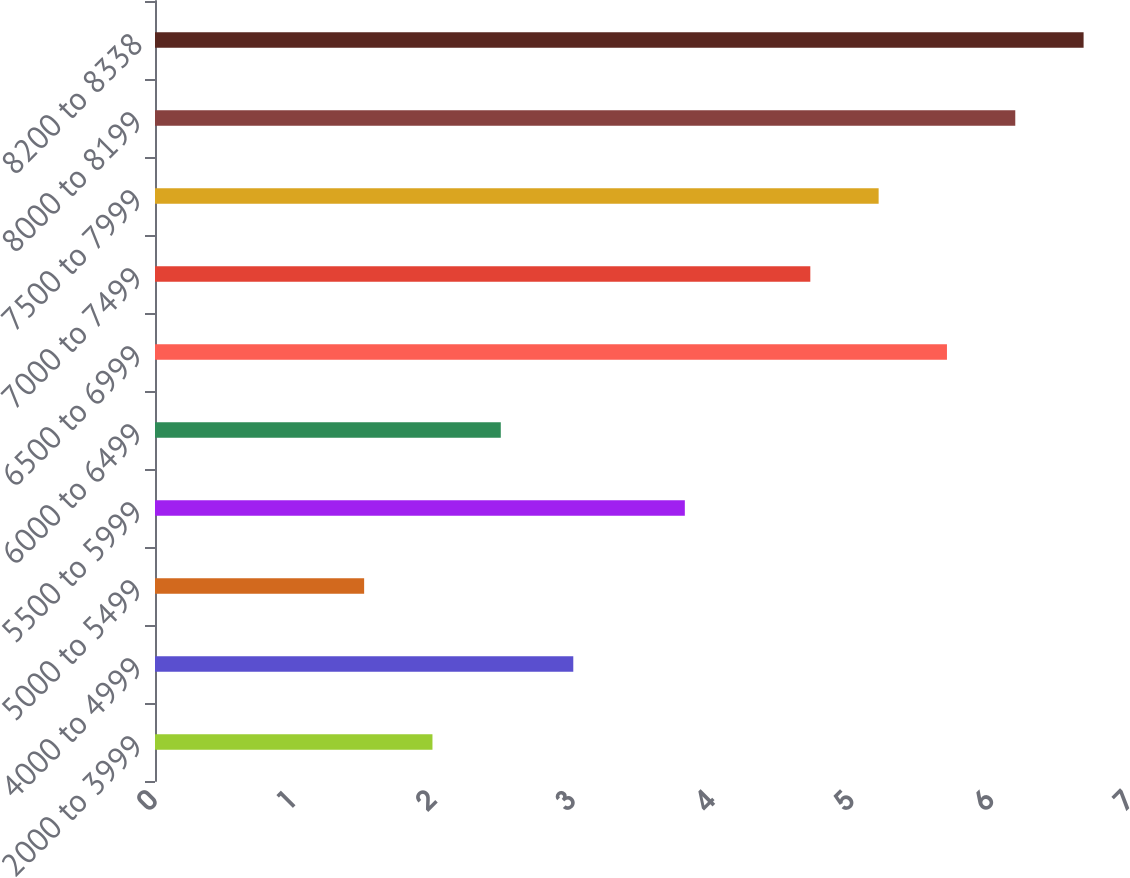<chart> <loc_0><loc_0><loc_500><loc_500><bar_chart><fcel>2000 to 3999<fcel>4000 to 4999<fcel>5000 to 5499<fcel>5500 to 5999<fcel>6000 to 6499<fcel>6500 to 6999<fcel>7000 to 7499<fcel>7500 to 7999<fcel>8000 to 8199<fcel>8200 to 8338<nl><fcel>1.99<fcel>3<fcel>1.5<fcel>3.8<fcel>2.48<fcel>5.68<fcel>4.7<fcel>5.19<fcel>6.17<fcel>6.66<nl></chart> 